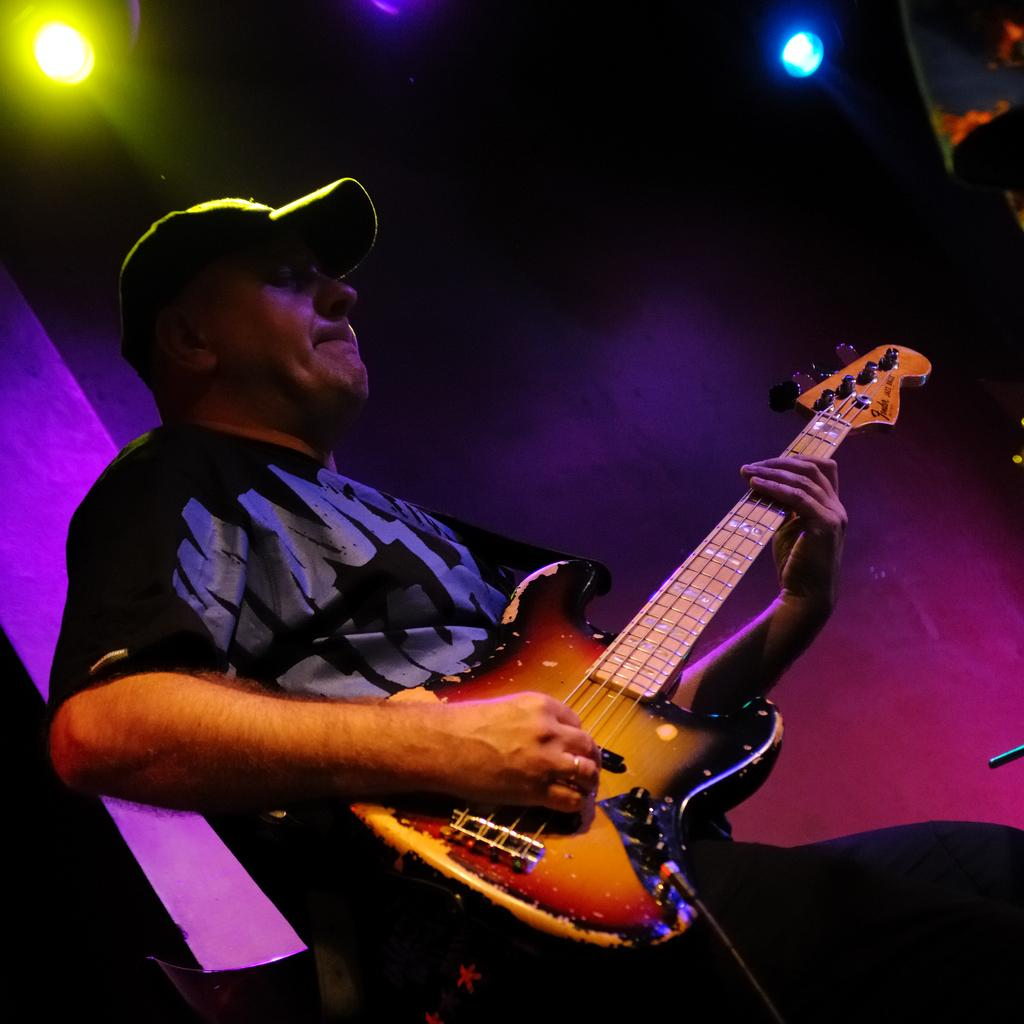What is the man in the image doing? The man is playing a guitar. Can you describe the man's attire in the image? The man is wearing a cap. What can be seen in the background of the image? There are lights visible in the background of the image. What type of furniture is the man sitting on in the image? There is no furniture visible in the image; it only shows the man playing a guitar. How does the man's behavior change throughout the image? The image only captures a single moment, so it does not show any change in the man's behavior. 